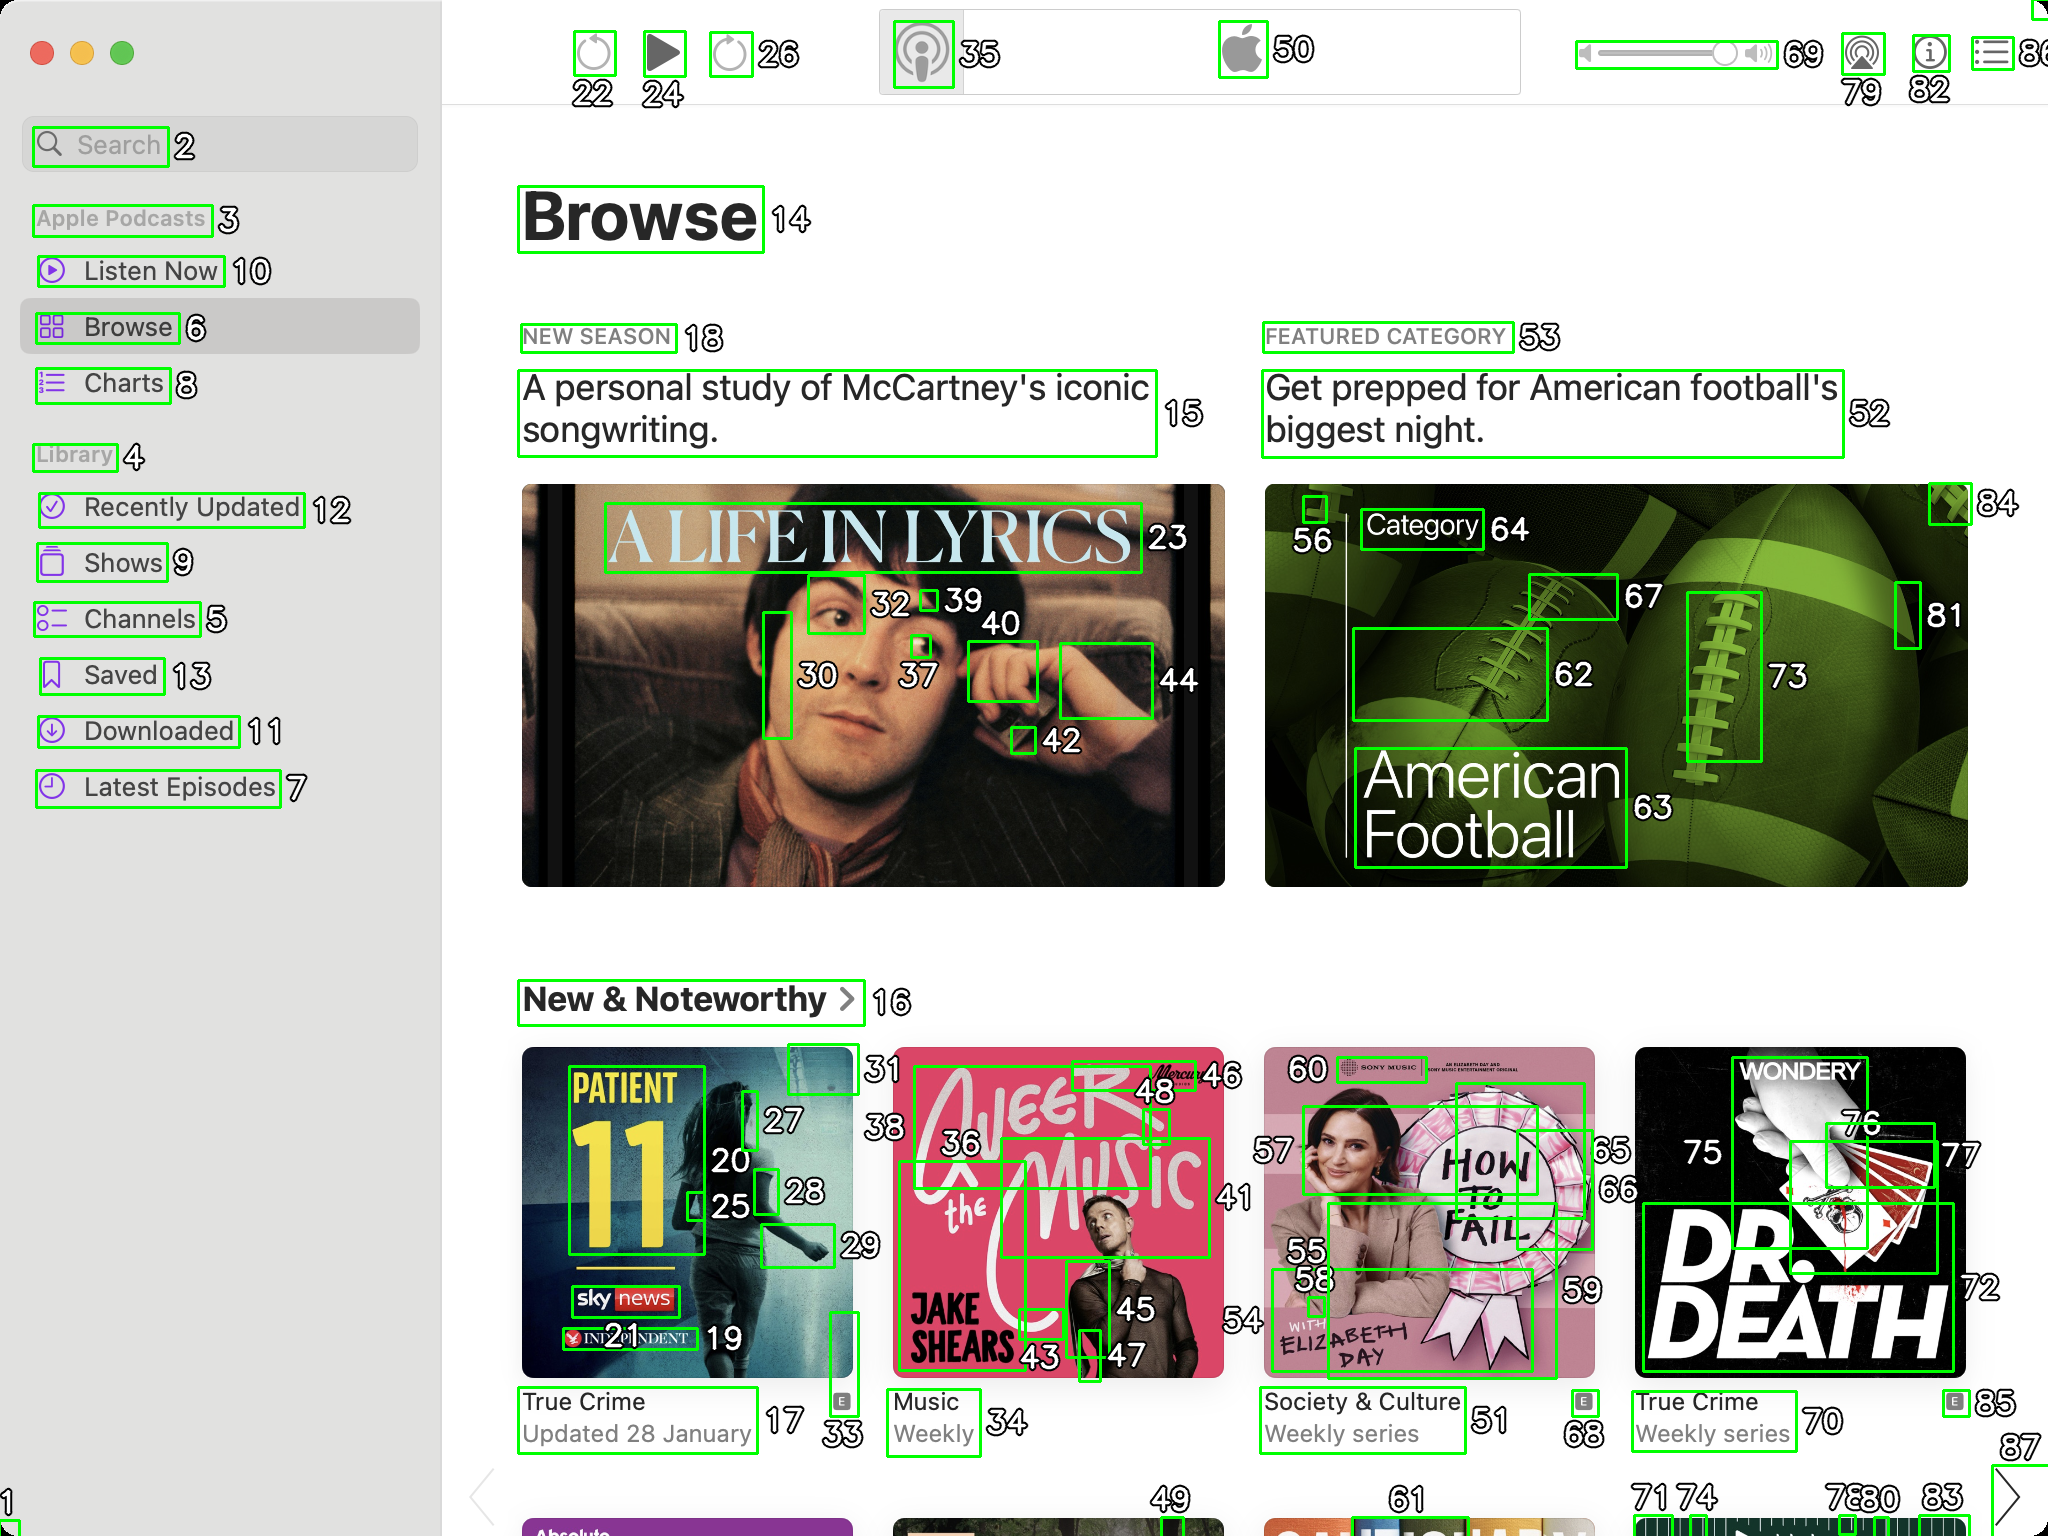You're an AI tasked with image processing and segmentation analyses. You've been specially designed to merge segmented regions of an image based on certain criteria to enhance accuracy and readability.
Your task is to address a user's concern with a UI screenshot of the Apple Podcasts application on MacOS, where the segmentation needs to be refined. The screenshot contains multiple green boxes, each representing a UI element, with a unique white number outlined in black from 1 to 100. Due to segmentation issues, some boxes that belong to the same UI element are being divided unnaturally.
Your goal is to merge these segmented areas that correspond to a single UI element to create a more coherent representation. The final output should be in JSON format, where each key-value pair would represent the merged areas.
For example, if boxes with numbers 1, 2, and 3 should belong to the same UI element, the JSON output could look like:
```json
{
"UI Element 1": [1, 2, 3]
}
```
Remember, your primary objective is to accurately merge the segmented regions based on the user's supplied image information while maintaining the integrity and structure of the UI elements in the Apple Podcasts application on MacOS. To address the segmentation issues and merge the segmented areas corresponding to a single UI element, I analyzed the provided screenshot and identified the numbers that should be grouped together into coherent regions. Here is the JSON representation of the merged areas:

```json
{
  "Search Bar": [1, 2],
  "Apple Podcasts Label": [3],
  "Listen Now": [10],
  "Browse": [6, 14],
  "Library": [4],
  "Recently Updated": [12],
  "Shows": [9],
  "Channels": [5],
  "Saved": [13],
  "Downloaded": [11],
  "Latest Episodes": [7],
  "New Season Label": [18],
  "A Personal Study of McCartney's Iconic Songwriting": [15],
  "Main Image Left": [20, 23, 25, 27, 28, 30, 32, 37, 39, 40, 42, 44],
  "Main Image Right": [52, 62, 63, 64, 67, 73, 81, 84],
  "Featured Category": [53],
  "Get Prepped for American Football's Biggest Night": [52],
  "New & Noteworthy Label": [16],
  "First Noteworthy Item": [17, 19, 21, 24, 26, 28, 33, 34],
  "Second Noteworthy Item": [35, 36, 43, 45, 46, 48],
  "Third Noteworthy Item": [49, 55, 56, 57, 58, 59, 60],
  "Fourth Noteworthy Item": [51, 66, 68, 70],
  "Top Right Controls": [22, 24, 26, 35, 50, 69, 79, 82]
}
```

This JSON output merges the segmented regions that seem to belong to the same UI elements, providing a more coherent structure. Each key represents a UI element, and the associated array contains the numbers of the boxes that should be merged for that element. 